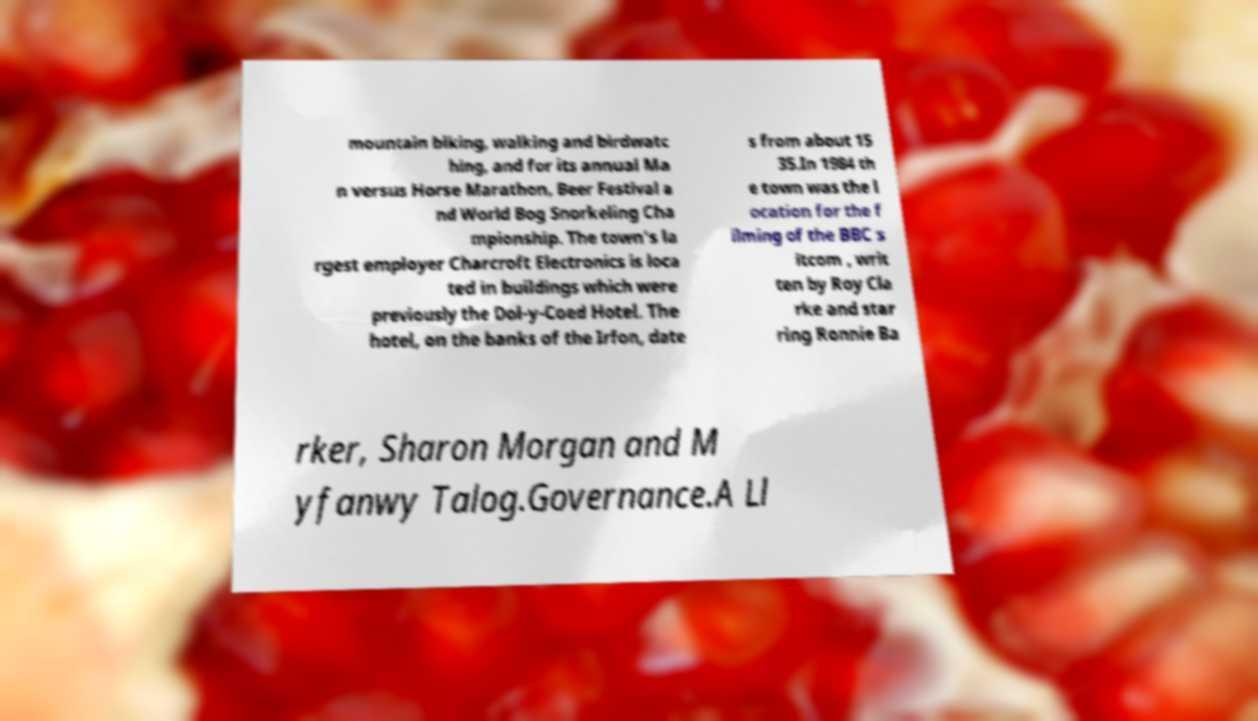What messages or text are displayed in this image? I need them in a readable, typed format. mountain biking, walking and birdwatc hing, and for its annual Ma n versus Horse Marathon, Beer Festival a nd World Bog Snorkeling Cha mpionship. The town's la rgest employer Charcroft Electronics is loca ted in buildings which were previously the Dol-y-Coed Hotel. The hotel, on the banks of the Irfon, date s from about 15 35.In 1984 th e town was the l ocation for the f ilming of the BBC s itcom , writ ten by Roy Cla rke and star ring Ronnie Ba rker, Sharon Morgan and M yfanwy Talog.Governance.A Ll 